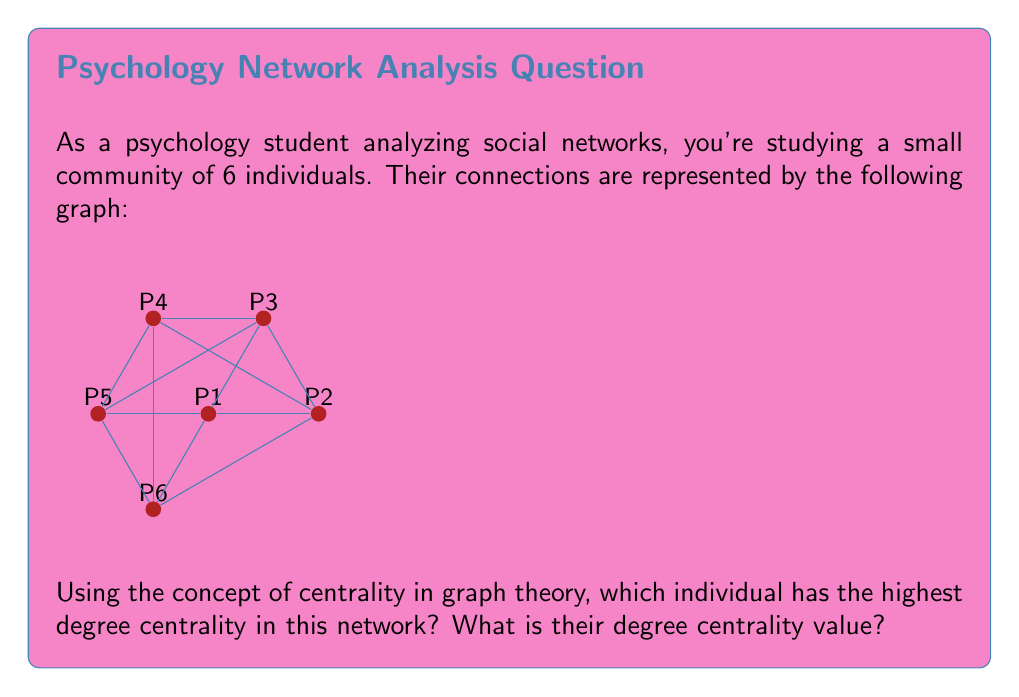Show me your answer to this math problem. To solve this problem, we need to understand and apply the concept of degree centrality in graph theory:

1. Degree centrality is a measure of the number of direct connections an individual (node) has in a network.

2. For each node (person) in the graph, we count the number of edges (connections) it has:

   P1: 4 connections
   P2: 4 connections
   P3: 4 connections
   P4: 4 connections
   P5: 4 connections
   P6: 4 connections

3. We can see that all nodes have the same number of connections (4).

4. To calculate the degree centrality value, we use the formula:

   $$ C_D(v) = \frac{deg(v)}{n - 1} $$

   Where $C_D(v)$ is the degree centrality of node $v$, $deg(v)$ is the degree (number of connections) of node $v$, and $n$ is the total number of nodes in the network.

5. For any node in this network:

   $$ C_D(v) = \frac{4}{6 - 1} = \frac{4}{5} = 0.8 $$

6. Since all nodes have the same degree centrality value, they all have the highest degree centrality in this network.
Answer: All individuals; 0.8 